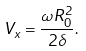<formula> <loc_0><loc_0><loc_500><loc_500>V _ { x } = \frac { \omega R _ { 0 } ^ { 2 } } { 2 \delta } .</formula> 